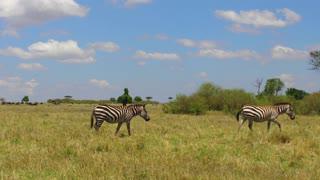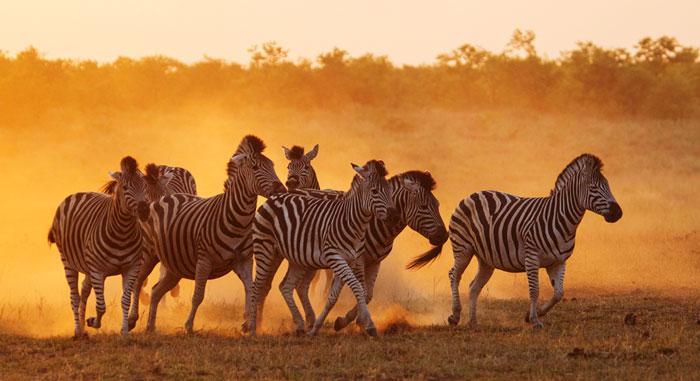The first image is the image on the left, the second image is the image on the right. For the images displayed, is the sentence "In one image there are exactly three zebras present and the other shows more than three." factually correct? Answer yes or no. No. The first image is the image on the left, the second image is the image on the right. Considering the images on both sides, is "The left image contains at least three times as many zebras as the right image." valid? Answer yes or no. No. 